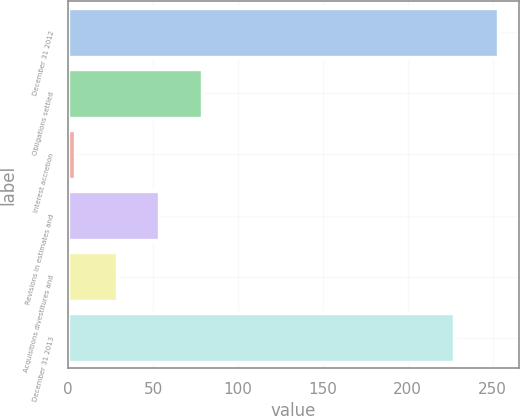Convert chart. <chart><loc_0><loc_0><loc_500><loc_500><bar_chart><fcel>December 31 2012<fcel>Obligations settled<fcel>Interest accretion<fcel>Revisions in estimates and<fcel>Acquisitions divestitures and<fcel>December 31 2013<nl><fcel>253<fcel>78.7<fcel>4<fcel>53.8<fcel>28.9<fcel>227<nl></chart> 